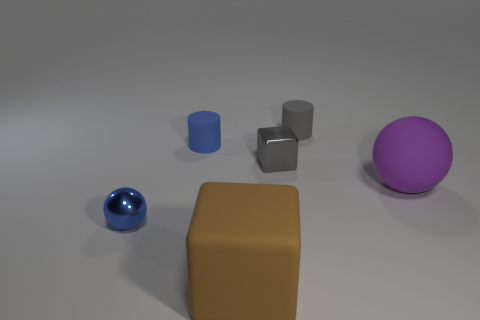What number of big brown objects are the same material as the small gray cylinder?
Give a very brief answer. 1. Are there any shiny objects?
Your response must be concise. Yes. How many objects are the same color as the metallic ball?
Make the answer very short. 1. Is the material of the small gray block the same as the ball that is in front of the large purple matte ball?
Keep it short and to the point. Yes. Is the number of metallic objects that are to the left of the large brown object greater than the number of tiny blue metal things?
Make the answer very short. No. Is there anything else that is the same size as the gray metal object?
Provide a succinct answer. Yes. There is a shiny sphere; does it have the same color as the small cylinder in front of the small gray cylinder?
Make the answer very short. Yes. Is the number of rubber cylinders that are on the right side of the gray cylinder the same as the number of big blocks in front of the rubber cube?
Offer a very short reply. Yes. There is a gray object that is in front of the gray matte cylinder; what material is it?
Ensure brevity in your answer.  Metal. How many objects are either matte objects on the left side of the brown cube or big brown objects?
Ensure brevity in your answer.  2. 